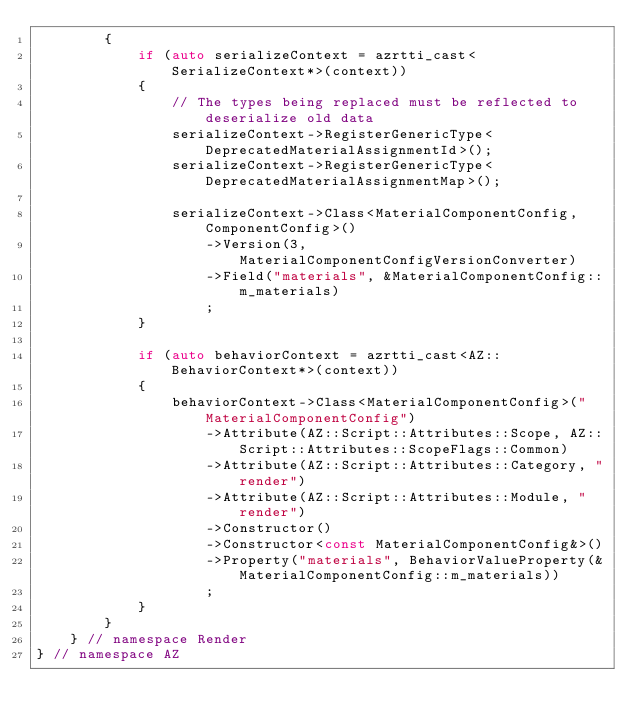<code> <loc_0><loc_0><loc_500><loc_500><_C++_>        {
            if (auto serializeContext = azrtti_cast<SerializeContext*>(context))
            {
                // The types being replaced must be reflected to deserialize old data
                serializeContext->RegisterGenericType<DeprecatedMaterialAssignmentId>();
                serializeContext->RegisterGenericType<DeprecatedMaterialAssignmentMap>();

                serializeContext->Class<MaterialComponentConfig, ComponentConfig>()
                    ->Version(3, MaterialComponentConfigVersionConverter)
                    ->Field("materials", &MaterialComponentConfig::m_materials)
                    ;
            }

            if (auto behaviorContext = azrtti_cast<AZ::BehaviorContext*>(context))
            {
                behaviorContext->Class<MaterialComponentConfig>("MaterialComponentConfig")
                    ->Attribute(AZ::Script::Attributes::Scope, AZ::Script::Attributes::ScopeFlags::Common)
                    ->Attribute(AZ::Script::Attributes::Category, "render")
                    ->Attribute(AZ::Script::Attributes::Module, "render")
                    ->Constructor()
                    ->Constructor<const MaterialComponentConfig&>()
                    ->Property("materials", BehaviorValueProperty(&MaterialComponentConfig::m_materials))
                    ;
            }
        }
    } // namespace Render
} // namespace AZ
</code> 